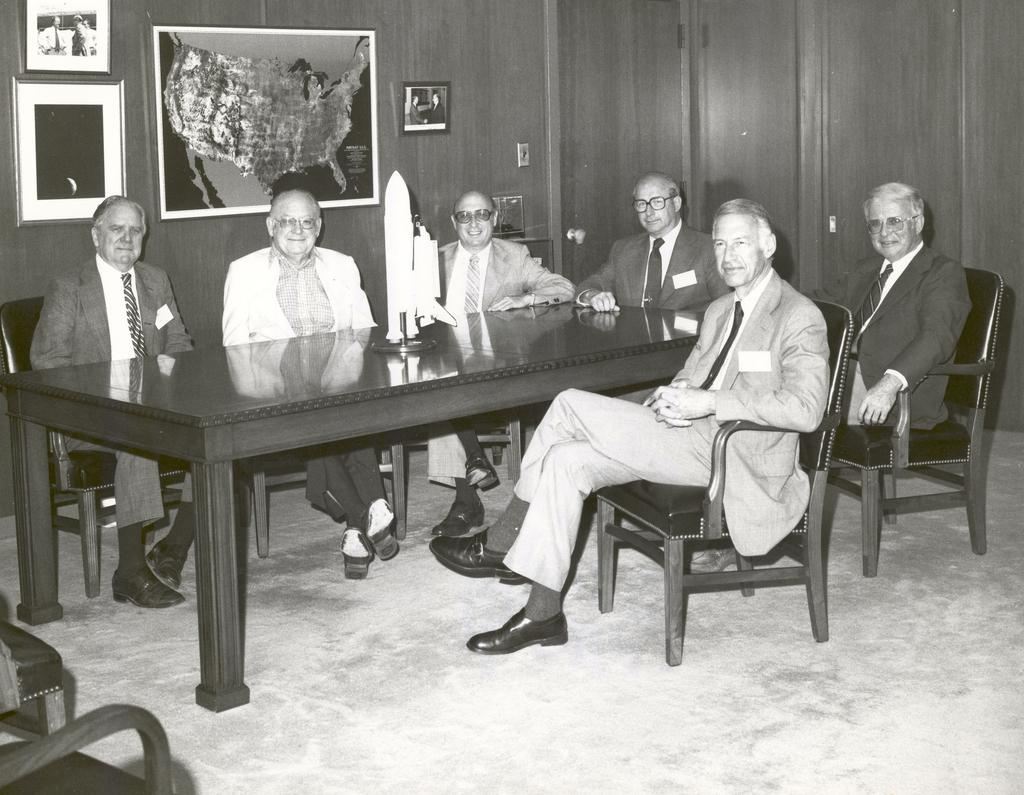What type of furniture is present in the image? There are chairs and a table in the image. What is on top of the table? There is a rocket-like object on the table. What are the people in the image doing? There are people sitting in the chairs. What can be seen on the wall in the image? There are photos on the wall. What type of steel is used in the rocket-like object? There is no mention of steel in the image. The rocket-like object is not described in terms of its material. --- Facts: 1. There is a car in the image. 2. The car is red. 3. The car has four wheels. 4. The car has a sunroof. 5. The car is parked on the street. Absurd Topics: elephant, ocean, rainbow Conversation: What type of vehicle is in the image? There is a car in the image. What color is the car? The car is red. How many wheels does the car have? The car has four wheels. What special feature does the car have? The car has a sunroof. Where is the car located in the image? The car is parked on the street. Reasoning: Let's think step by step in order to produce the conversation. We start by identifying the main subject of the image, which is the car. Next, we describe specific features of the car, such as its color, the number of wheels, and the presence of a sunroof. Then, we observe the location of the car in the image, which is parked on the street. Finally, we ensure that the language is simple and clear. Absurd Question/Answer: Can you see an elephant riding in the red car in the image? There is no elephant present in the image. The image only features a red car parked on the street. --- Facts: 1. There is a group of people in the image. 2. The people are wearing hats. 3. The people are holding hands. 4. The people are standing in front of a building. 5. The building has a large clock on its facade. Absurd Topics: unicorn, flying saucer, outer space Conversation: How many people are in the image? There is a group of people in the image. What are the people wearing on their heads? The people are wearing hats. What are the people doing in the image? The people are holding hands. What can be seen behind the people in the image? The people are standing in front of a building. What feature of the building can be seen in the image? The building has a large clock on its facade. Reasoning: Let's think step by step in order to produce the conversation. 